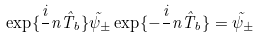<formula> <loc_0><loc_0><loc_500><loc_500>\exp \{ \frac { i } { } n \hat { T } _ { b } \} \tilde { \psi } _ { \pm } \exp \{ - \frac { i } { } n \hat { T } _ { b } \} = \tilde { \psi } _ { \pm }</formula> 